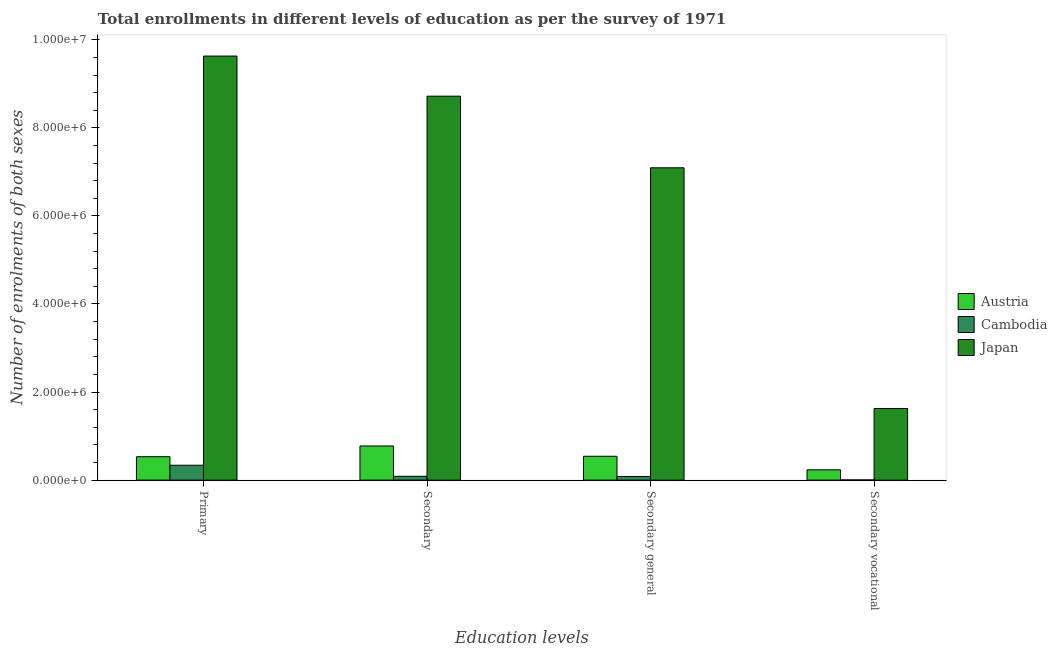Are the number of bars per tick equal to the number of legend labels?
Your response must be concise. Yes. How many bars are there on the 3rd tick from the left?
Your answer should be very brief. 3. What is the label of the 4th group of bars from the left?
Ensure brevity in your answer.  Secondary vocational. What is the number of enrolments in secondary education in Austria?
Ensure brevity in your answer.  7.75e+05. Across all countries, what is the maximum number of enrolments in secondary general education?
Provide a short and direct response. 7.09e+06. Across all countries, what is the minimum number of enrolments in secondary education?
Your answer should be very brief. 8.70e+04. In which country was the number of enrolments in primary education maximum?
Your answer should be compact. Japan. In which country was the number of enrolments in secondary vocational education minimum?
Provide a short and direct response. Cambodia. What is the total number of enrolments in secondary vocational education in the graph?
Provide a short and direct response. 1.86e+06. What is the difference between the number of enrolments in secondary vocational education in Austria and that in Japan?
Offer a very short reply. -1.39e+06. What is the difference between the number of enrolments in secondary vocational education in Japan and the number of enrolments in secondary education in Austria?
Keep it short and to the point. 8.51e+05. What is the average number of enrolments in primary education per country?
Your answer should be very brief. 3.50e+06. What is the difference between the number of enrolments in secondary vocational education and number of enrolments in secondary general education in Japan?
Your response must be concise. -5.47e+06. In how many countries, is the number of enrolments in secondary general education greater than 1600000 ?
Your answer should be very brief. 1. What is the ratio of the number of enrolments in secondary education in Austria to that in Cambodia?
Keep it short and to the point. 8.91. Is the number of enrolments in secondary general education in Japan less than that in Cambodia?
Offer a very short reply. No. Is the difference between the number of enrolments in secondary education in Austria and Japan greater than the difference between the number of enrolments in secondary vocational education in Austria and Japan?
Offer a very short reply. No. What is the difference between the highest and the second highest number of enrolments in secondary vocational education?
Offer a very short reply. 1.39e+06. What is the difference between the highest and the lowest number of enrolments in secondary vocational education?
Offer a very short reply. 1.62e+06. Is the sum of the number of enrolments in secondary vocational education in Austria and Japan greater than the maximum number of enrolments in secondary education across all countries?
Your response must be concise. No. What does the 3rd bar from the left in Secondary general represents?
Your answer should be compact. Japan. What does the 2nd bar from the right in Secondary represents?
Make the answer very short. Cambodia. Is it the case that in every country, the sum of the number of enrolments in primary education and number of enrolments in secondary education is greater than the number of enrolments in secondary general education?
Offer a terse response. Yes. How many bars are there?
Your answer should be compact. 12. How many countries are there in the graph?
Keep it short and to the point. 3. What is the difference between two consecutive major ticks on the Y-axis?
Keep it short and to the point. 2.00e+06. Does the graph contain any zero values?
Provide a succinct answer. No. Where does the legend appear in the graph?
Give a very brief answer. Center right. What is the title of the graph?
Offer a terse response. Total enrollments in different levels of education as per the survey of 1971. Does "Latin America(developing only)" appear as one of the legend labels in the graph?
Your response must be concise. No. What is the label or title of the X-axis?
Provide a succinct answer. Education levels. What is the label or title of the Y-axis?
Keep it short and to the point. Number of enrolments of both sexes. What is the Number of enrolments of both sexes in Austria in Primary?
Ensure brevity in your answer.  5.32e+05. What is the Number of enrolments of both sexes of Cambodia in Primary?
Provide a succinct answer. 3.38e+05. What is the Number of enrolments of both sexes in Japan in Primary?
Give a very brief answer. 9.63e+06. What is the Number of enrolments of both sexes of Austria in Secondary?
Your response must be concise. 7.75e+05. What is the Number of enrolments of both sexes of Cambodia in Secondary?
Provide a short and direct response. 8.70e+04. What is the Number of enrolments of both sexes in Japan in Secondary?
Provide a short and direct response. 8.72e+06. What is the Number of enrolments of both sexes of Austria in Secondary general?
Your answer should be compact. 5.42e+05. What is the Number of enrolments of both sexes in Cambodia in Secondary general?
Keep it short and to the point. 8.27e+04. What is the Number of enrolments of both sexes in Japan in Secondary general?
Provide a succinct answer. 7.09e+06. What is the Number of enrolments of both sexes of Austria in Secondary vocational?
Your answer should be very brief. 2.34e+05. What is the Number of enrolments of both sexes of Cambodia in Secondary vocational?
Provide a succinct answer. 4299. What is the Number of enrolments of both sexes in Japan in Secondary vocational?
Ensure brevity in your answer.  1.63e+06. Across all Education levels, what is the maximum Number of enrolments of both sexes of Austria?
Provide a short and direct response. 7.75e+05. Across all Education levels, what is the maximum Number of enrolments of both sexes in Cambodia?
Your answer should be very brief. 3.38e+05. Across all Education levels, what is the maximum Number of enrolments of both sexes in Japan?
Your answer should be compact. 9.63e+06. Across all Education levels, what is the minimum Number of enrolments of both sexes of Austria?
Your response must be concise. 2.34e+05. Across all Education levels, what is the minimum Number of enrolments of both sexes of Cambodia?
Your answer should be very brief. 4299. Across all Education levels, what is the minimum Number of enrolments of both sexes of Japan?
Give a very brief answer. 1.63e+06. What is the total Number of enrolments of both sexes of Austria in the graph?
Your answer should be very brief. 2.08e+06. What is the total Number of enrolments of both sexes in Cambodia in the graph?
Keep it short and to the point. 5.12e+05. What is the total Number of enrolments of both sexes of Japan in the graph?
Your response must be concise. 2.71e+07. What is the difference between the Number of enrolments of both sexes in Austria in Primary and that in Secondary?
Your response must be concise. -2.43e+05. What is the difference between the Number of enrolments of both sexes in Cambodia in Primary and that in Secondary?
Provide a short and direct response. 2.51e+05. What is the difference between the Number of enrolments of both sexes of Japan in Primary and that in Secondary?
Keep it short and to the point. 9.11e+05. What is the difference between the Number of enrolments of both sexes of Austria in Primary and that in Secondary general?
Your answer should be very brief. -9784. What is the difference between the Number of enrolments of both sexes of Cambodia in Primary and that in Secondary general?
Provide a succinct answer. 2.55e+05. What is the difference between the Number of enrolments of both sexes in Japan in Primary and that in Secondary general?
Ensure brevity in your answer.  2.54e+06. What is the difference between the Number of enrolments of both sexes in Austria in Primary and that in Secondary vocational?
Keep it short and to the point. 2.98e+05. What is the difference between the Number of enrolments of both sexes in Cambodia in Primary and that in Secondary vocational?
Make the answer very short. 3.33e+05. What is the difference between the Number of enrolments of both sexes in Japan in Primary and that in Secondary vocational?
Provide a short and direct response. 8.00e+06. What is the difference between the Number of enrolments of both sexes of Austria in Secondary and that in Secondary general?
Ensure brevity in your answer.  2.34e+05. What is the difference between the Number of enrolments of both sexes of Cambodia in Secondary and that in Secondary general?
Keep it short and to the point. 4299. What is the difference between the Number of enrolments of both sexes in Japan in Secondary and that in Secondary general?
Your answer should be compact. 1.63e+06. What is the difference between the Number of enrolments of both sexes in Austria in Secondary and that in Secondary vocational?
Offer a very short reply. 5.42e+05. What is the difference between the Number of enrolments of both sexes of Cambodia in Secondary and that in Secondary vocational?
Offer a terse response. 8.27e+04. What is the difference between the Number of enrolments of both sexes of Japan in Secondary and that in Secondary vocational?
Offer a very short reply. 7.09e+06. What is the difference between the Number of enrolments of both sexes in Austria in Secondary general and that in Secondary vocational?
Provide a short and direct response. 3.08e+05. What is the difference between the Number of enrolments of both sexes of Cambodia in Secondary general and that in Secondary vocational?
Offer a terse response. 7.84e+04. What is the difference between the Number of enrolments of both sexes in Japan in Secondary general and that in Secondary vocational?
Ensure brevity in your answer.  5.47e+06. What is the difference between the Number of enrolments of both sexes in Austria in Primary and the Number of enrolments of both sexes in Cambodia in Secondary?
Offer a terse response. 4.45e+05. What is the difference between the Number of enrolments of both sexes of Austria in Primary and the Number of enrolments of both sexes of Japan in Secondary?
Offer a terse response. -8.19e+06. What is the difference between the Number of enrolments of both sexes in Cambodia in Primary and the Number of enrolments of both sexes in Japan in Secondary?
Ensure brevity in your answer.  -8.38e+06. What is the difference between the Number of enrolments of both sexes in Austria in Primary and the Number of enrolments of both sexes in Cambodia in Secondary general?
Give a very brief answer. 4.49e+05. What is the difference between the Number of enrolments of both sexes of Austria in Primary and the Number of enrolments of both sexes of Japan in Secondary general?
Offer a terse response. -6.56e+06. What is the difference between the Number of enrolments of both sexes in Cambodia in Primary and the Number of enrolments of both sexes in Japan in Secondary general?
Your response must be concise. -6.76e+06. What is the difference between the Number of enrolments of both sexes of Austria in Primary and the Number of enrolments of both sexes of Cambodia in Secondary vocational?
Make the answer very short. 5.28e+05. What is the difference between the Number of enrolments of both sexes in Austria in Primary and the Number of enrolments of both sexes in Japan in Secondary vocational?
Your response must be concise. -1.09e+06. What is the difference between the Number of enrolments of both sexes in Cambodia in Primary and the Number of enrolments of both sexes in Japan in Secondary vocational?
Your answer should be very brief. -1.29e+06. What is the difference between the Number of enrolments of both sexes of Austria in Secondary and the Number of enrolments of both sexes of Cambodia in Secondary general?
Offer a terse response. 6.93e+05. What is the difference between the Number of enrolments of both sexes in Austria in Secondary and the Number of enrolments of both sexes in Japan in Secondary general?
Offer a terse response. -6.32e+06. What is the difference between the Number of enrolments of both sexes of Cambodia in Secondary and the Number of enrolments of both sexes of Japan in Secondary general?
Provide a succinct answer. -7.01e+06. What is the difference between the Number of enrolments of both sexes in Austria in Secondary and the Number of enrolments of both sexes in Cambodia in Secondary vocational?
Give a very brief answer. 7.71e+05. What is the difference between the Number of enrolments of both sexes in Austria in Secondary and the Number of enrolments of both sexes in Japan in Secondary vocational?
Your answer should be compact. -8.51e+05. What is the difference between the Number of enrolments of both sexes of Cambodia in Secondary and the Number of enrolments of both sexes of Japan in Secondary vocational?
Give a very brief answer. -1.54e+06. What is the difference between the Number of enrolments of both sexes of Austria in Secondary general and the Number of enrolments of both sexes of Cambodia in Secondary vocational?
Offer a very short reply. 5.37e+05. What is the difference between the Number of enrolments of both sexes of Austria in Secondary general and the Number of enrolments of both sexes of Japan in Secondary vocational?
Offer a very short reply. -1.08e+06. What is the difference between the Number of enrolments of both sexes in Cambodia in Secondary general and the Number of enrolments of both sexes in Japan in Secondary vocational?
Keep it short and to the point. -1.54e+06. What is the average Number of enrolments of both sexes of Austria per Education levels?
Provide a short and direct response. 5.21e+05. What is the average Number of enrolments of both sexes in Cambodia per Education levels?
Your answer should be very brief. 1.28e+05. What is the average Number of enrolments of both sexes of Japan per Education levels?
Your answer should be very brief. 6.77e+06. What is the difference between the Number of enrolments of both sexes in Austria and Number of enrolments of both sexes in Cambodia in Primary?
Make the answer very short. 1.94e+05. What is the difference between the Number of enrolments of both sexes of Austria and Number of enrolments of both sexes of Japan in Primary?
Provide a succinct answer. -9.10e+06. What is the difference between the Number of enrolments of both sexes in Cambodia and Number of enrolments of both sexes in Japan in Primary?
Keep it short and to the point. -9.29e+06. What is the difference between the Number of enrolments of both sexes of Austria and Number of enrolments of both sexes of Cambodia in Secondary?
Your response must be concise. 6.88e+05. What is the difference between the Number of enrolments of both sexes of Austria and Number of enrolments of both sexes of Japan in Secondary?
Provide a succinct answer. -7.94e+06. What is the difference between the Number of enrolments of both sexes of Cambodia and Number of enrolments of both sexes of Japan in Secondary?
Your answer should be compact. -8.63e+06. What is the difference between the Number of enrolments of both sexes in Austria and Number of enrolments of both sexes in Cambodia in Secondary general?
Offer a terse response. 4.59e+05. What is the difference between the Number of enrolments of both sexes of Austria and Number of enrolments of both sexes of Japan in Secondary general?
Keep it short and to the point. -6.55e+06. What is the difference between the Number of enrolments of both sexes of Cambodia and Number of enrolments of both sexes of Japan in Secondary general?
Your answer should be very brief. -7.01e+06. What is the difference between the Number of enrolments of both sexes of Austria and Number of enrolments of both sexes of Cambodia in Secondary vocational?
Your answer should be compact. 2.29e+05. What is the difference between the Number of enrolments of both sexes in Austria and Number of enrolments of both sexes in Japan in Secondary vocational?
Your response must be concise. -1.39e+06. What is the difference between the Number of enrolments of both sexes in Cambodia and Number of enrolments of both sexes in Japan in Secondary vocational?
Offer a very short reply. -1.62e+06. What is the ratio of the Number of enrolments of both sexes of Austria in Primary to that in Secondary?
Offer a terse response. 0.69. What is the ratio of the Number of enrolments of both sexes in Cambodia in Primary to that in Secondary?
Provide a succinct answer. 3.88. What is the ratio of the Number of enrolments of both sexes in Japan in Primary to that in Secondary?
Provide a short and direct response. 1.1. What is the ratio of the Number of enrolments of both sexes of Austria in Primary to that in Secondary general?
Offer a terse response. 0.98. What is the ratio of the Number of enrolments of both sexes in Cambodia in Primary to that in Secondary general?
Your answer should be very brief. 4.08. What is the ratio of the Number of enrolments of both sexes in Japan in Primary to that in Secondary general?
Offer a terse response. 1.36. What is the ratio of the Number of enrolments of both sexes in Austria in Primary to that in Secondary vocational?
Provide a succinct answer. 2.28. What is the ratio of the Number of enrolments of both sexes of Cambodia in Primary to that in Secondary vocational?
Keep it short and to the point. 78.56. What is the ratio of the Number of enrolments of both sexes in Japan in Primary to that in Secondary vocational?
Your response must be concise. 5.92. What is the ratio of the Number of enrolments of both sexes in Austria in Secondary to that in Secondary general?
Offer a terse response. 1.43. What is the ratio of the Number of enrolments of both sexes of Cambodia in Secondary to that in Secondary general?
Offer a terse response. 1.05. What is the ratio of the Number of enrolments of both sexes in Japan in Secondary to that in Secondary general?
Provide a succinct answer. 1.23. What is the ratio of the Number of enrolments of both sexes in Austria in Secondary to that in Secondary vocational?
Ensure brevity in your answer.  3.32. What is the ratio of the Number of enrolments of both sexes in Cambodia in Secondary to that in Secondary vocational?
Your answer should be very brief. 20.24. What is the ratio of the Number of enrolments of both sexes in Japan in Secondary to that in Secondary vocational?
Provide a succinct answer. 5.36. What is the ratio of the Number of enrolments of both sexes of Austria in Secondary general to that in Secondary vocational?
Offer a very short reply. 2.32. What is the ratio of the Number of enrolments of both sexes of Cambodia in Secondary general to that in Secondary vocational?
Your answer should be compact. 19.24. What is the ratio of the Number of enrolments of both sexes of Japan in Secondary general to that in Secondary vocational?
Provide a succinct answer. 4.36. What is the difference between the highest and the second highest Number of enrolments of both sexes of Austria?
Offer a very short reply. 2.34e+05. What is the difference between the highest and the second highest Number of enrolments of both sexes in Cambodia?
Ensure brevity in your answer.  2.51e+05. What is the difference between the highest and the second highest Number of enrolments of both sexes of Japan?
Offer a very short reply. 9.11e+05. What is the difference between the highest and the lowest Number of enrolments of both sexes in Austria?
Ensure brevity in your answer.  5.42e+05. What is the difference between the highest and the lowest Number of enrolments of both sexes in Cambodia?
Give a very brief answer. 3.33e+05. What is the difference between the highest and the lowest Number of enrolments of both sexes in Japan?
Keep it short and to the point. 8.00e+06. 